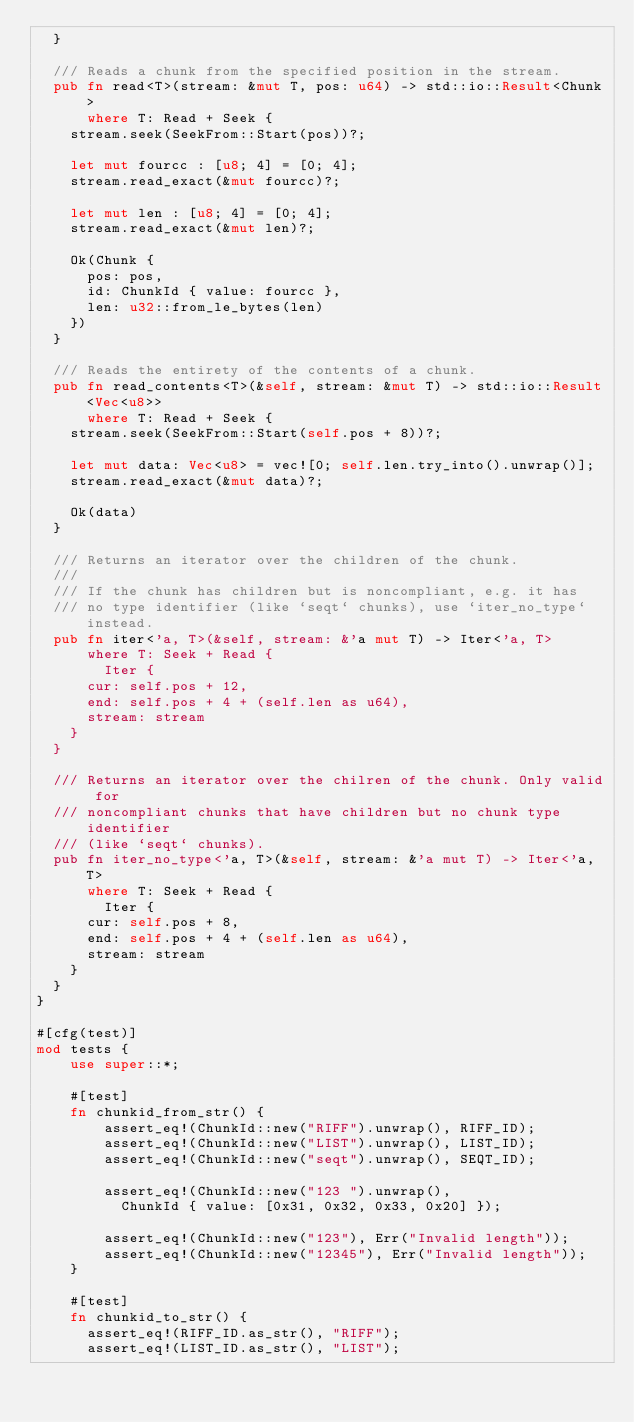<code> <loc_0><loc_0><loc_500><loc_500><_Rust_>  }

  /// Reads a chunk from the specified position in the stream.
  pub fn read<T>(stream: &mut T, pos: u64) -> std::io::Result<Chunk>
      where T: Read + Seek {
    stream.seek(SeekFrom::Start(pos))?;

    let mut fourcc : [u8; 4] = [0; 4];
    stream.read_exact(&mut fourcc)?;

    let mut len : [u8; 4] = [0; 4];
    stream.read_exact(&mut len)?;

    Ok(Chunk {
      pos: pos,
      id: ChunkId { value: fourcc },
      len: u32::from_le_bytes(len)
    })
  }
  
  /// Reads the entirety of the contents of a chunk.
  pub fn read_contents<T>(&self, stream: &mut T) -> std::io::Result<Vec<u8>>
      where T: Read + Seek {
    stream.seek(SeekFrom::Start(self.pos + 8))?;

    let mut data: Vec<u8> = vec![0; self.len.try_into().unwrap()];
    stream.read_exact(&mut data)?;

    Ok(data)
  }

  /// Returns an iterator over the children of the chunk.
  /// 
  /// If the chunk has children but is noncompliant, e.g. it has
  /// no type identifier (like `seqt` chunks), use `iter_no_type` instead.
  pub fn iter<'a, T>(&self, stream: &'a mut T) -> Iter<'a, T>
      where T: Seek + Read {
        Iter {
      cur: self.pos + 12,
      end: self.pos + 4 + (self.len as u64),
      stream: stream
    }
  }

  /// Returns an iterator over the chilren of the chunk. Only valid for
  /// noncompliant chunks that have children but no chunk type identifier
  /// (like `seqt` chunks).
  pub fn iter_no_type<'a, T>(&self, stream: &'a mut T) -> Iter<'a, T>
      where T: Seek + Read {
        Iter {
      cur: self.pos + 8,
      end: self.pos + 4 + (self.len as u64),
      stream: stream
    }
  }
}

#[cfg(test)]
mod tests {
    use super::*;

    #[test]
    fn chunkid_from_str() {
        assert_eq!(ChunkId::new("RIFF").unwrap(), RIFF_ID);
        assert_eq!(ChunkId::new("LIST").unwrap(), LIST_ID);
        assert_eq!(ChunkId::new("seqt").unwrap(), SEQT_ID);

        assert_eq!(ChunkId::new("123 ").unwrap(),
          ChunkId { value: [0x31, 0x32, 0x33, 0x20] });

        assert_eq!(ChunkId::new("123"), Err("Invalid length"));
        assert_eq!(ChunkId::new("12345"), Err("Invalid length"));
    }

    #[test]
    fn chunkid_to_str() {
      assert_eq!(RIFF_ID.as_str(), "RIFF");
      assert_eq!(LIST_ID.as_str(), "LIST");</code> 